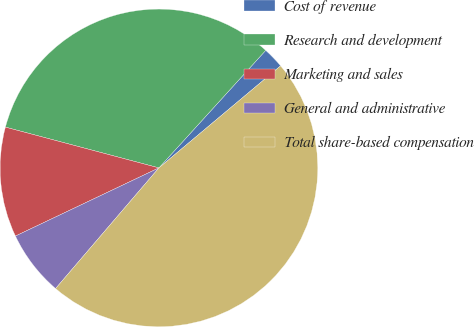Convert chart. <chart><loc_0><loc_0><loc_500><loc_500><pie_chart><fcel>Cost of revenue<fcel>Research and development<fcel>Marketing and sales<fcel>General and administrative<fcel>Total share-based compensation<nl><fcel>2.15%<fcel>32.61%<fcel>11.19%<fcel>6.67%<fcel>47.38%<nl></chart> 